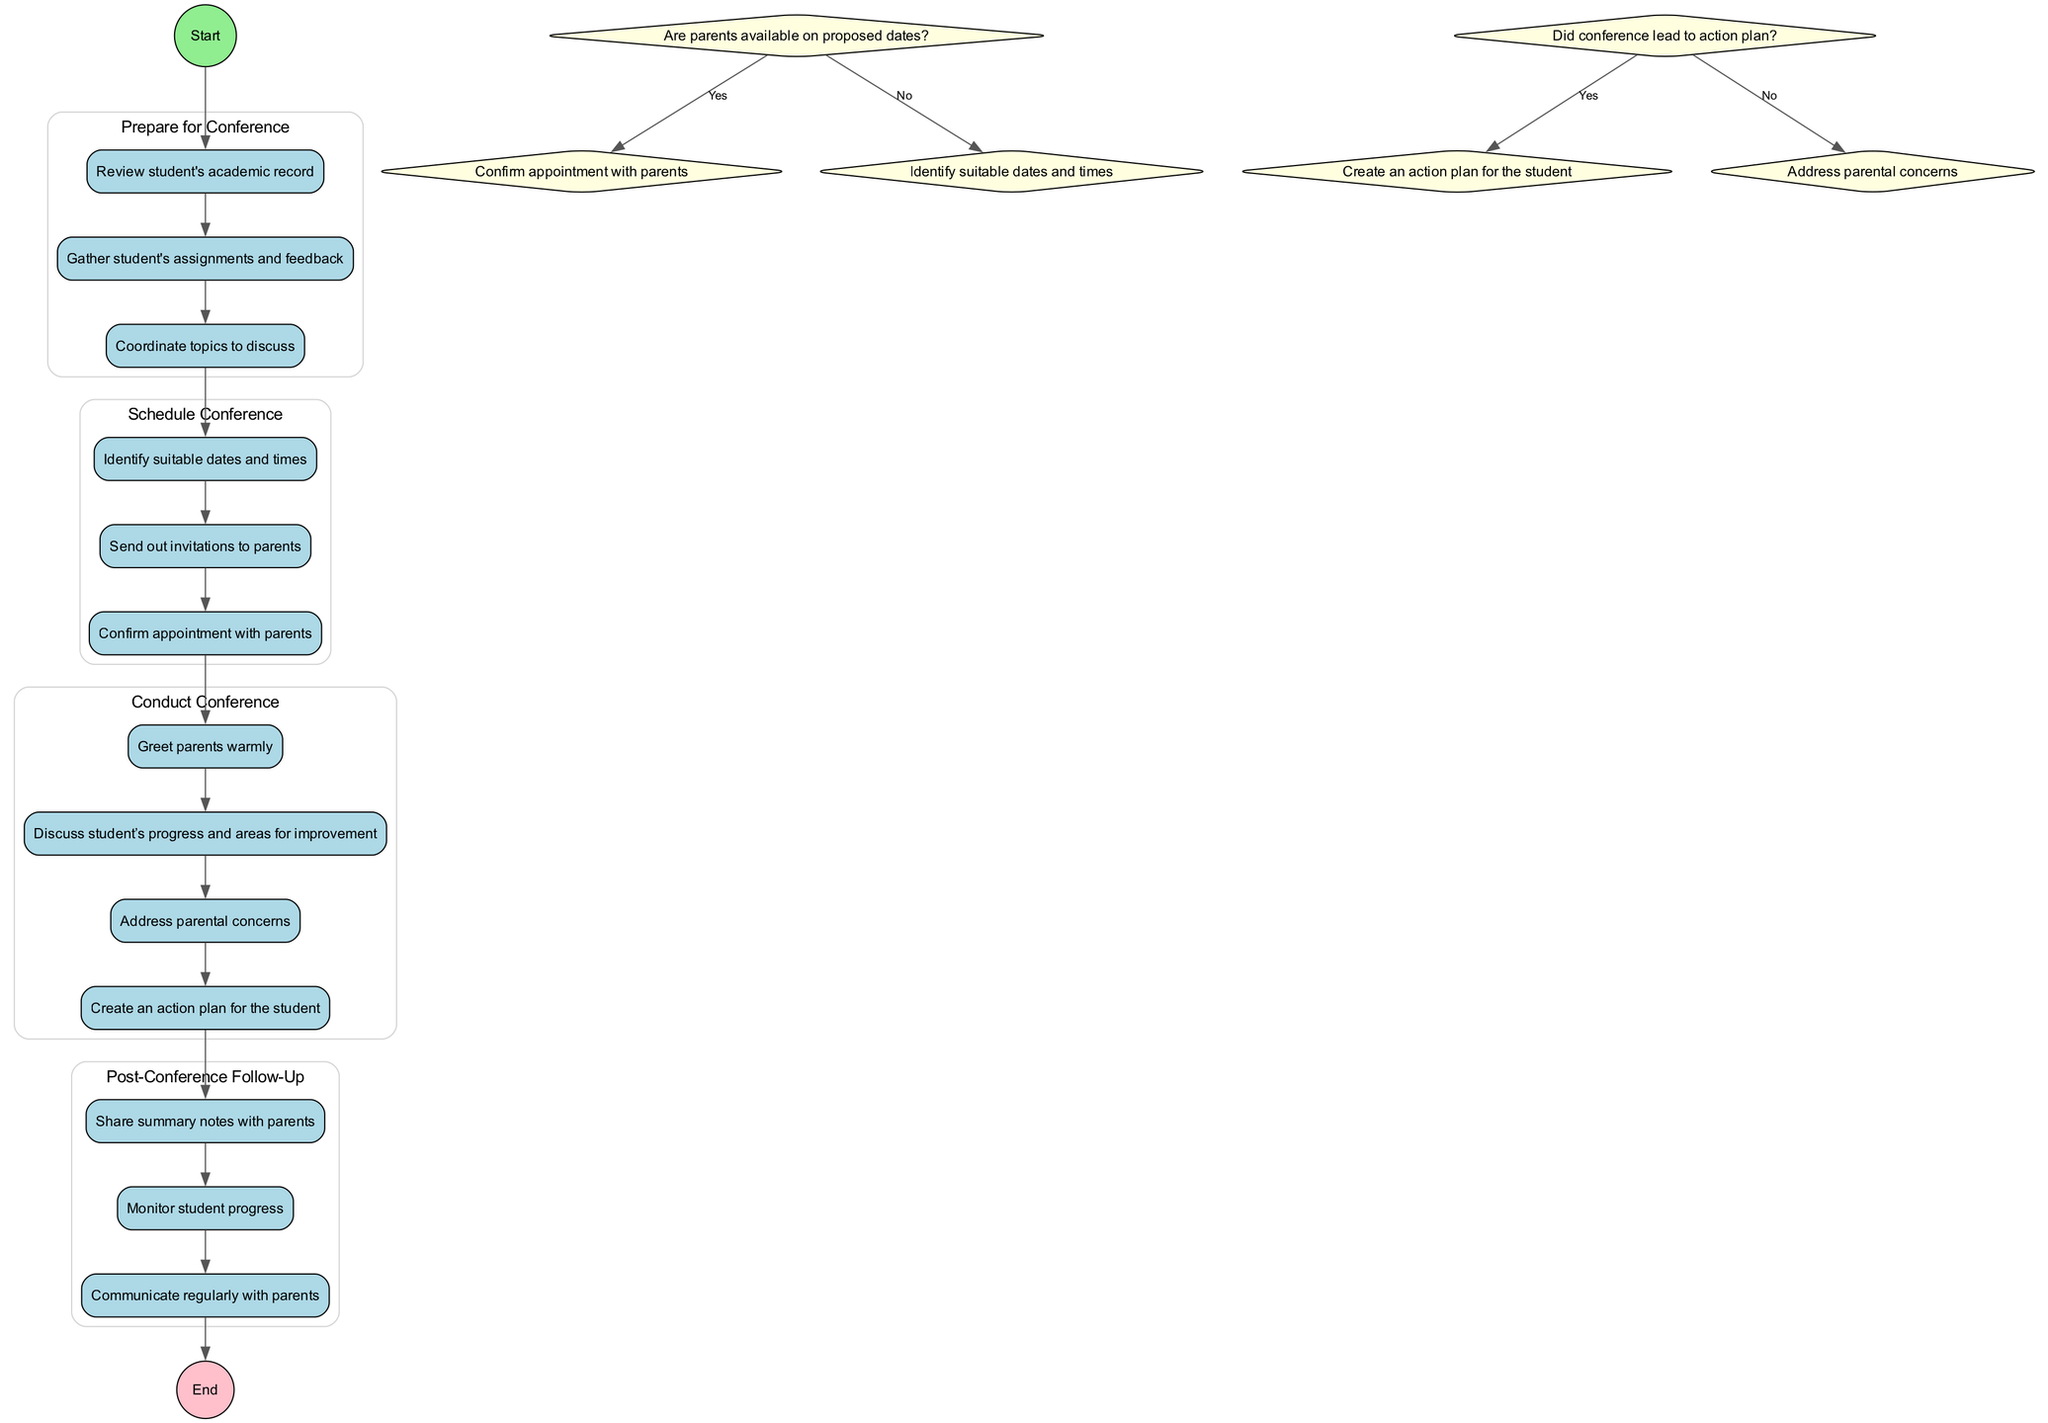What is the starting activity in the diagram? The starting activity is labeled as "Prepare for Conference," which is the first activity node following the "Start" node in the diagram.
Answer: Prepare for Conference How many activities are depicted in the diagram? The diagram shows four activities: "Prepare for Conference," "Schedule Conference," "Conduct Conference," and "Post-Conference Follow-Up." By counting these activities, we find a total of four.
Answer: Four What is the end point of the flow in the diagram? The end point is indicated as "Post-Conference Follow-Up," which is the last activity before the "End" node in the diagram.
Answer: Post-Conference Follow-Up What decision point follows after scheduling the conference? The decision point that follows scheduling the conference is "Are parents available on proposed dates?" This question is asked after sending out invitations and before confirming the appointment with parents.
Answer: Are parents available on proposed dates? If parents are not available, what is the next activity? If parents are not available, the next activity is "Identify suitable dates and times." This is the response action directed by the decision point regarding parents' availability.
Answer: Identify suitable dates and times How many actions are included in the "Conduct Conference" activity? The "Conduct Conference" activity includes four actions: greeting parents, discussing student progress and areas for improvement, addressing parental concerns, and creating an action plan for the student. By counting these, we find four actions.
Answer: Four Which activity involves sharing summary notes with parents? The activity that involves sharing summary notes with parents is "Post-Conference Follow-Up." This action is part of the final phase after the conference is conducted.
Answer: Post-Conference Follow-Up What happens if the conference does not lead to an action plan? If the conference does not lead to an action plan, the next action is to "Address parental concerns." This is the alternative path specified in the decision point regarding the creation of an action plan.
Answer: Address parental concerns 